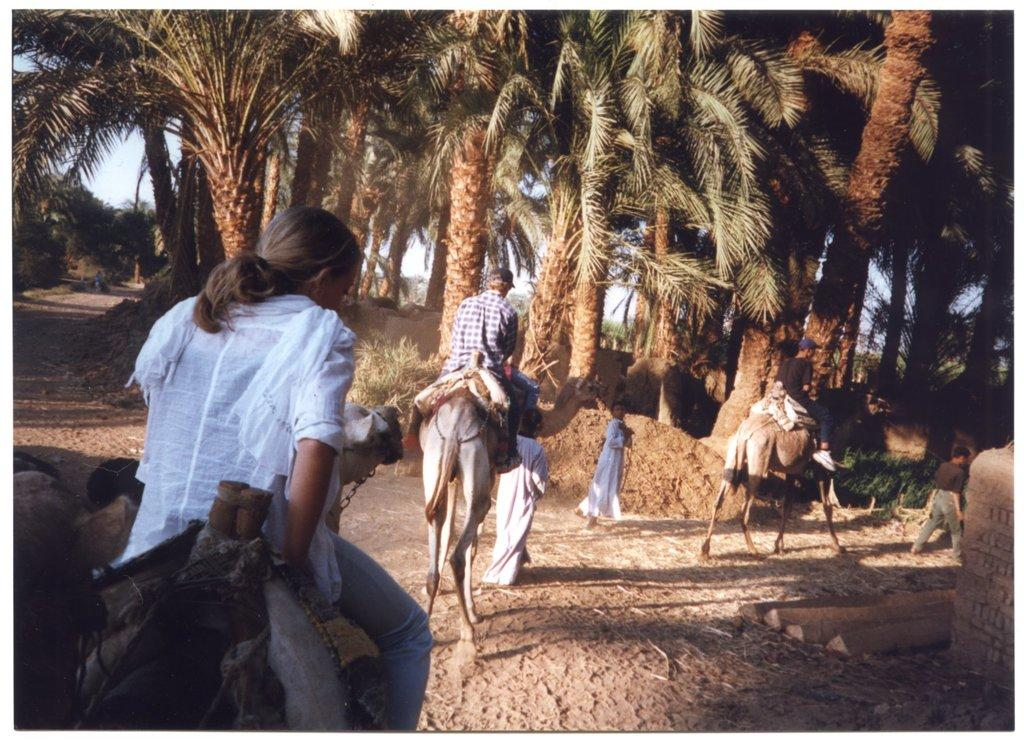Who or what can be seen in the image? There are people and camels in the image. What type of vegetation is present in the image? There are trees in the image. What is visible in the background of the image? The sky is visible in the image. What type of list can be seen in the image? There is no list present in the image. How does the volcano affect the image? There is no volcano present in the image. 